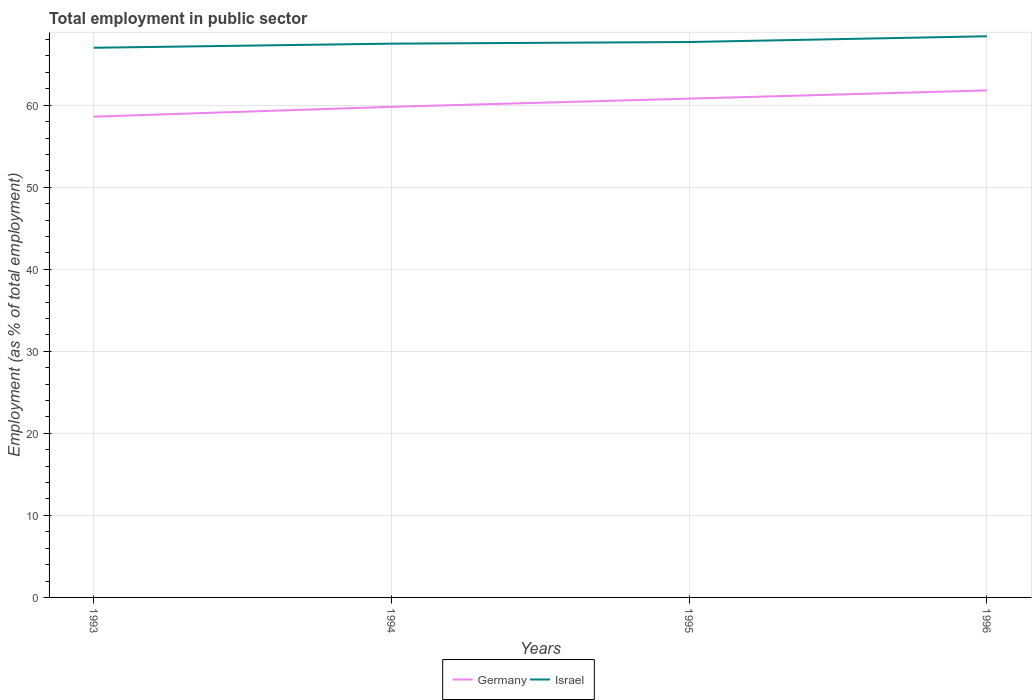How many different coloured lines are there?
Offer a very short reply. 2. Does the line corresponding to Israel intersect with the line corresponding to Germany?
Your response must be concise. No. Is the number of lines equal to the number of legend labels?
Provide a succinct answer. Yes. In which year was the employment in public sector in Germany maximum?
Give a very brief answer. 1993. What is the total employment in public sector in Germany in the graph?
Your answer should be compact. -2.2. What is the difference between the highest and the second highest employment in public sector in Germany?
Make the answer very short. 3.2. Does the graph contain any zero values?
Your response must be concise. No. Where does the legend appear in the graph?
Offer a terse response. Bottom center. How are the legend labels stacked?
Offer a very short reply. Horizontal. What is the title of the graph?
Provide a short and direct response. Total employment in public sector. Does "Ecuador" appear as one of the legend labels in the graph?
Your answer should be compact. No. What is the label or title of the X-axis?
Ensure brevity in your answer.  Years. What is the label or title of the Y-axis?
Provide a succinct answer. Employment (as % of total employment). What is the Employment (as % of total employment) in Germany in 1993?
Ensure brevity in your answer.  58.6. What is the Employment (as % of total employment) in Israel in 1993?
Offer a very short reply. 67. What is the Employment (as % of total employment) in Germany in 1994?
Make the answer very short. 59.8. What is the Employment (as % of total employment) of Israel in 1994?
Offer a terse response. 67.5. What is the Employment (as % of total employment) in Germany in 1995?
Offer a very short reply. 60.8. What is the Employment (as % of total employment) in Israel in 1995?
Provide a short and direct response. 67.7. What is the Employment (as % of total employment) in Germany in 1996?
Offer a terse response. 61.8. What is the Employment (as % of total employment) in Israel in 1996?
Give a very brief answer. 68.4. Across all years, what is the maximum Employment (as % of total employment) of Germany?
Provide a succinct answer. 61.8. Across all years, what is the maximum Employment (as % of total employment) in Israel?
Keep it short and to the point. 68.4. Across all years, what is the minimum Employment (as % of total employment) of Germany?
Offer a very short reply. 58.6. Across all years, what is the minimum Employment (as % of total employment) of Israel?
Ensure brevity in your answer.  67. What is the total Employment (as % of total employment) in Germany in the graph?
Offer a terse response. 241. What is the total Employment (as % of total employment) of Israel in the graph?
Offer a terse response. 270.6. What is the difference between the Employment (as % of total employment) in Germany in 1993 and that in 1994?
Give a very brief answer. -1.2. What is the difference between the Employment (as % of total employment) in Israel in 1993 and that in 1994?
Ensure brevity in your answer.  -0.5. What is the difference between the Employment (as % of total employment) in Israel in 1993 and that in 1995?
Your response must be concise. -0.7. What is the difference between the Employment (as % of total employment) of Germany in 1994 and that in 1995?
Your response must be concise. -1. What is the difference between the Employment (as % of total employment) in Israel in 1994 and that in 1995?
Offer a very short reply. -0.2. What is the difference between the Employment (as % of total employment) in Germany in 1995 and that in 1996?
Your answer should be compact. -1. What is the difference between the Employment (as % of total employment) of Germany in 1993 and the Employment (as % of total employment) of Israel in 1994?
Offer a very short reply. -8.9. What is the difference between the Employment (as % of total employment) of Germany in 1993 and the Employment (as % of total employment) of Israel in 1995?
Keep it short and to the point. -9.1. What is the difference between the Employment (as % of total employment) of Germany in 1994 and the Employment (as % of total employment) of Israel in 1996?
Offer a terse response. -8.6. What is the difference between the Employment (as % of total employment) in Germany in 1995 and the Employment (as % of total employment) in Israel in 1996?
Make the answer very short. -7.6. What is the average Employment (as % of total employment) in Germany per year?
Provide a succinct answer. 60.25. What is the average Employment (as % of total employment) in Israel per year?
Your response must be concise. 67.65. What is the ratio of the Employment (as % of total employment) in Germany in 1993 to that in 1994?
Make the answer very short. 0.98. What is the ratio of the Employment (as % of total employment) of Germany in 1993 to that in 1995?
Offer a terse response. 0.96. What is the ratio of the Employment (as % of total employment) in Israel in 1993 to that in 1995?
Make the answer very short. 0.99. What is the ratio of the Employment (as % of total employment) in Germany in 1993 to that in 1996?
Your response must be concise. 0.95. What is the ratio of the Employment (as % of total employment) in Israel in 1993 to that in 1996?
Your answer should be compact. 0.98. What is the ratio of the Employment (as % of total employment) of Germany in 1994 to that in 1995?
Ensure brevity in your answer.  0.98. What is the ratio of the Employment (as % of total employment) in Israel in 1994 to that in 1995?
Your answer should be very brief. 1. What is the ratio of the Employment (as % of total employment) in Germany in 1994 to that in 1996?
Provide a short and direct response. 0.97. What is the ratio of the Employment (as % of total employment) of Germany in 1995 to that in 1996?
Offer a terse response. 0.98. What is the ratio of the Employment (as % of total employment) in Israel in 1995 to that in 1996?
Provide a short and direct response. 0.99. What is the difference between the highest and the second highest Employment (as % of total employment) in Israel?
Provide a short and direct response. 0.7. What is the difference between the highest and the lowest Employment (as % of total employment) of Israel?
Keep it short and to the point. 1.4. 